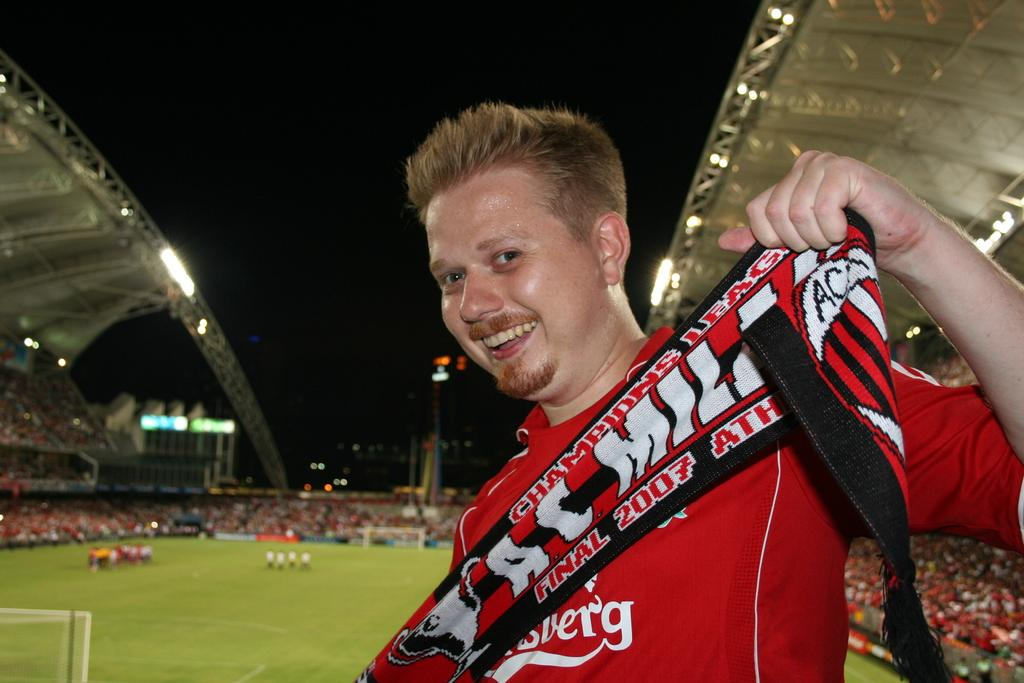<image>
Summarize the visual content of the image. A man holds up a scarf that says Champions League on it. 